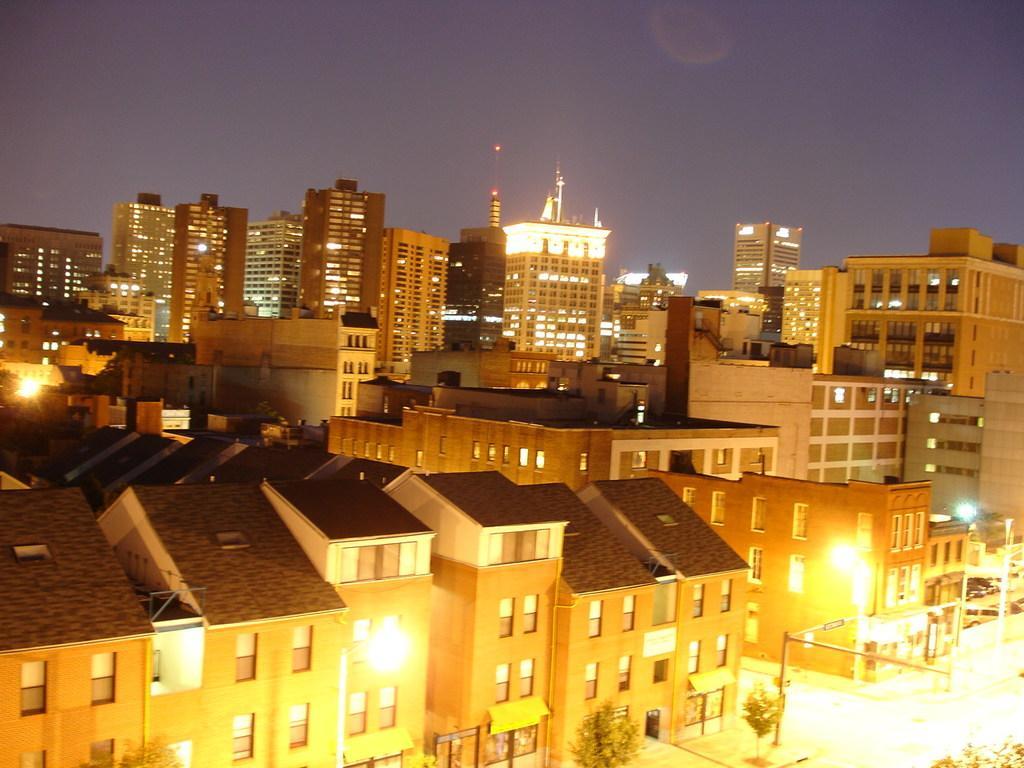Could you give a brief overview of what you see in this image? This image is clicked from a top view. There are buildings and skyscrapers in the image. At the top there is the sky. In the bottom right there is a road. Beside the road there is a walkway. There are plants and street light poles on the walkway. 